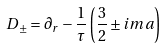Convert formula to latex. <formula><loc_0><loc_0><loc_500><loc_500>D _ { \pm } = \partial _ { r } - \frac { 1 } { \tau } \left ( \frac { 3 } { 2 } \pm i m a \right )</formula> 